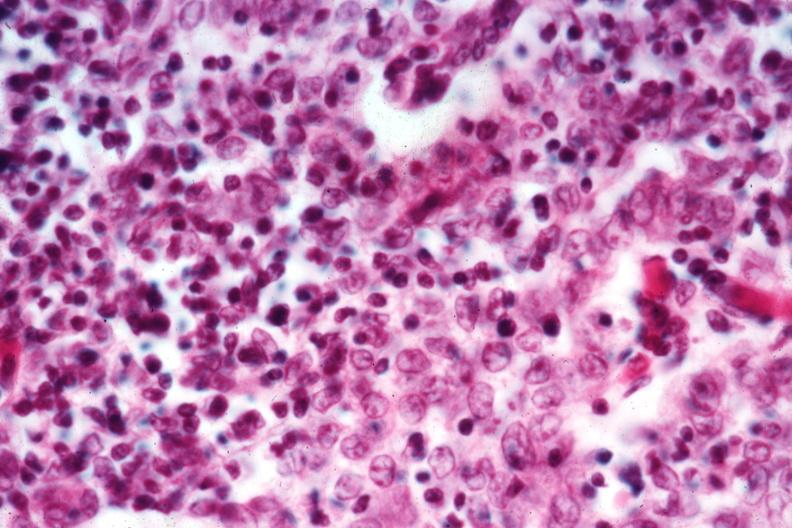what does this image show?
Answer the question using a single word or phrase. Cellular detail well shown 